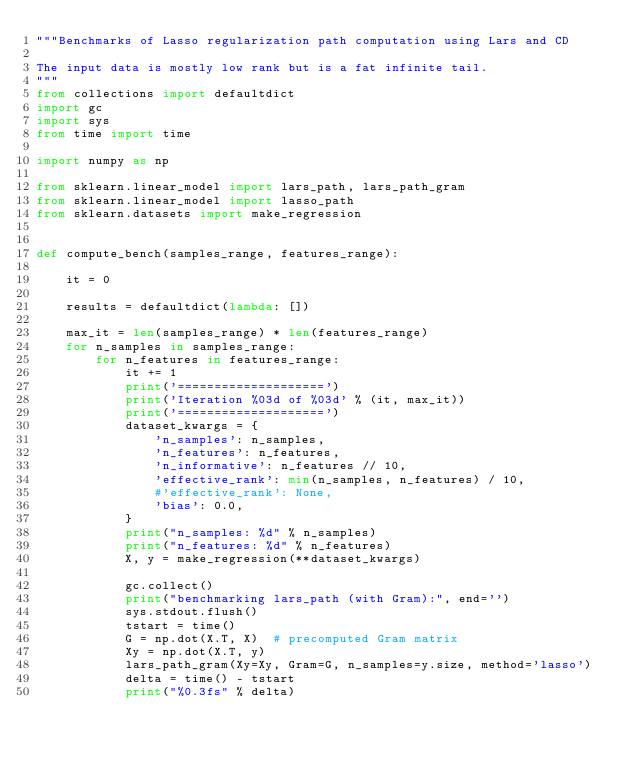<code> <loc_0><loc_0><loc_500><loc_500><_Python_>"""Benchmarks of Lasso regularization path computation using Lars and CD

The input data is mostly low rank but is a fat infinite tail.
"""
from collections import defaultdict
import gc
import sys
from time import time

import numpy as np

from sklearn.linear_model import lars_path, lars_path_gram
from sklearn.linear_model import lasso_path
from sklearn.datasets import make_regression


def compute_bench(samples_range, features_range):

    it = 0

    results = defaultdict(lambda: [])

    max_it = len(samples_range) * len(features_range)
    for n_samples in samples_range:
        for n_features in features_range:
            it += 1
            print('====================')
            print('Iteration %03d of %03d' % (it, max_it))
            print('====================')
            dataset_kwargs = {
                'n_samples': n_samples,
                'n_features': n_features,
                'n_informative': n_features // 10,
                'effective_rank': min(n_samples, n_features) / 10,
                #'effective_rank': None,
                'bias': 0.0,
            }
            print("n_samples: %d" % n_samples)
            print("n_features: %d" % n_features)
            X, y = make_regression(**dataset_kwargs)

            gc.collect()
            print("benchmarking lars_path (with Gram):", end='')
            sys.stdout.flush()
            tstart = time()
            G = np.dot(X.T, X)  # precomputed Gram matrix
            Xy = np.dot(X.T, y)
            lars_path_gram(Xy=Xy, Gram=G, n_samples=y.size, method='lasso')
            delta = time() - tstart
            print("%0.3fs" % delta)</code> 